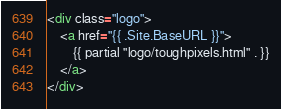Convert code to text. <code><loc_0><loc_0><loc_500><loc_500><_HTML_><div class="logo">
    <a href="{{ .Site.BaseURL }}">
        {{ partial "logo/toughpixels.html" . }}
    </a>
</div></code> 